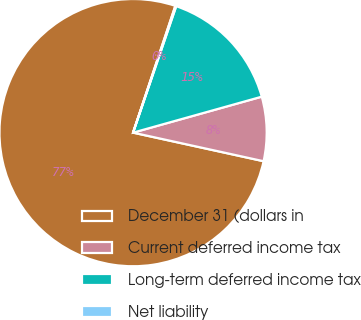Convert chart. <chart><loc_0><loc_0><loc_500><loc_500><pie_chart><fcel>December 31 (dollars in<fcel>Current deferred income tax<fcel>Long-term deferred income tax<fcel>Net liability<nl><fcel>76.69%<fcel>7.77%<fcel>15.43%<fcel>0.11%<nl></chart> 